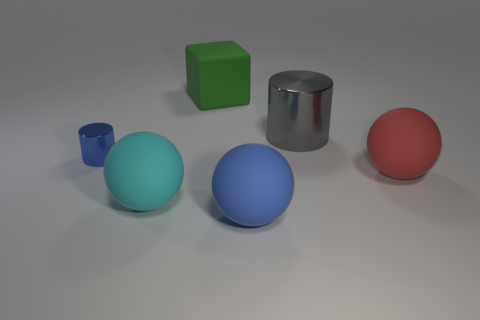What material is the object that is both left of the large green rubber block and on the right side of the blue metal thing?
Keep it short and to the point. Rubber. Is the tiny blue object the same shape as the big red object?
Offer a very short reply. No. Is there anything else that is the same size as the blue metallic thing?
Make the answer very short. No. There is a blue cylinder; how many gray objects are in front of it?
Your answer should be compact. 0. Do the blue rubber ball that is in front of the green cube and the gray cylinder have the same size?
Ensure brevity in your answer.  Yes. What is the color of the other object that is the same shape as the big gray thing?
Keep it short and to the point. Blue. Is there any other thing that has the same shape as the large gray shiny thing?
Your answer should be compact. Yes. What shape is the thing behind the big gray object?
Offer a very short reply. Cube. What number of other green rubber objects have the same shape as the big green rubber thing?
Offer a terse response. 0. There is a cylinder that is in front of the gray metallic cylinder; does it have the same color as the sphere that is in front of the large cyan ball?
Your answer should be very brief. Yes. 